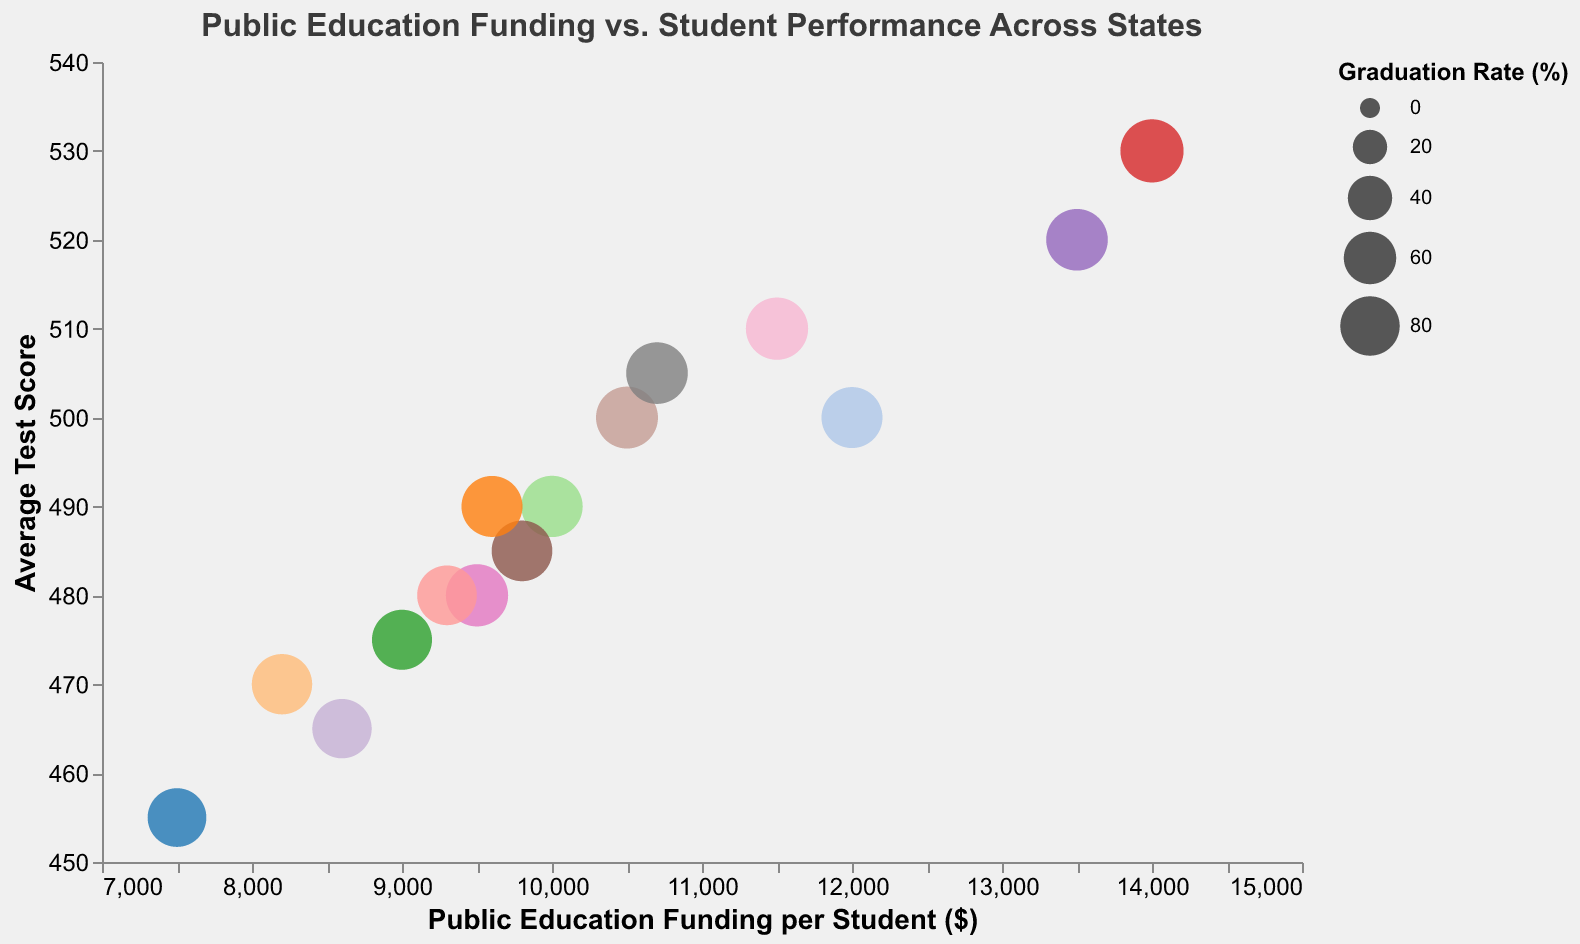What's the title of the chart? The title is typically located at the top of the chart. In this chart, the title is "Public Education Funding vs. Student Performance Across States."
Answer: Public Education Funding vs. Student Performance Across States What does the x-axis represent? The x-axis represents the "Public Education Funding per Student ($)." This information is displayed along the horizontal axis.
Answer: Public Education Funding per Student ($) Which state has the highest average test score? To determine the state with the highest average test score, look for the bubble highest on the y-axis, which represents "Average Test Score." The highest bubble corresponds to Massachusetts with an average test score of 530.
Answer: Massachusetts How many states have an average test score of 500 or higher? Identify the bubbles that are positioned at a y-axis value of 500 or higher. States meeting this criterion are California, Pennsylvania, Virginia, Washington, and Massachusetts, totaling 5 states.
Answer: 5 What's the difference in public education funding between California and Texas? California's funding per student is $12,000, while Texas's funding is $9,500. The difference is calculated as $12,000 - $9,500.
Answer: $2,500 Which state has the lowest graduation rate, and what is that rate? The size of the bubbles indicates the graduation rate. The smallest bubble corresponds to Arizona, which has a graduation rate of 78%.
Answer: Arizona, 78% Is there a clear relationship between public education funding and average test scores? Observing the distribution of bubbles along the x-axis and y-axis, there is no immediate and clear linear relationship. States with higher funding do not necessarily have the highest test scores, indicating that other factors might also affect performance.
Answer: No clear relationship What state with a funding of less than $10,000 has the highest average test score? Consider states with funding below $10,000 and compare their average test scores. Texas (480), Florida (470), Ohio (485), Georgia (475), North Carolina (465), Michigan (480), and Colorado (490) are candidates. The highest average test score among them is from Colorado at 490.
Answer: Colorado Which states have public education funding per student between $10,000 and $12,000? Look at the x-axis for bubbles within this range. Illinois ($10,000), Pennsylvania ($10,500), Washington ($10,700), and Virginia ($11,500) all fall within this range.
Answer: Illinois, Pennsylvania, Washington, Virginia How does Massachusetts compare to other states in terms of graduation rate? Massachusetts has a graduation rate of 92%, indicated by the large size of its bubble. Comparing to other states, Massachusetts has one of the highest graduation rates, surpassing all others based on the bubble sizes visible in the chart.
Answer: One of the highest 